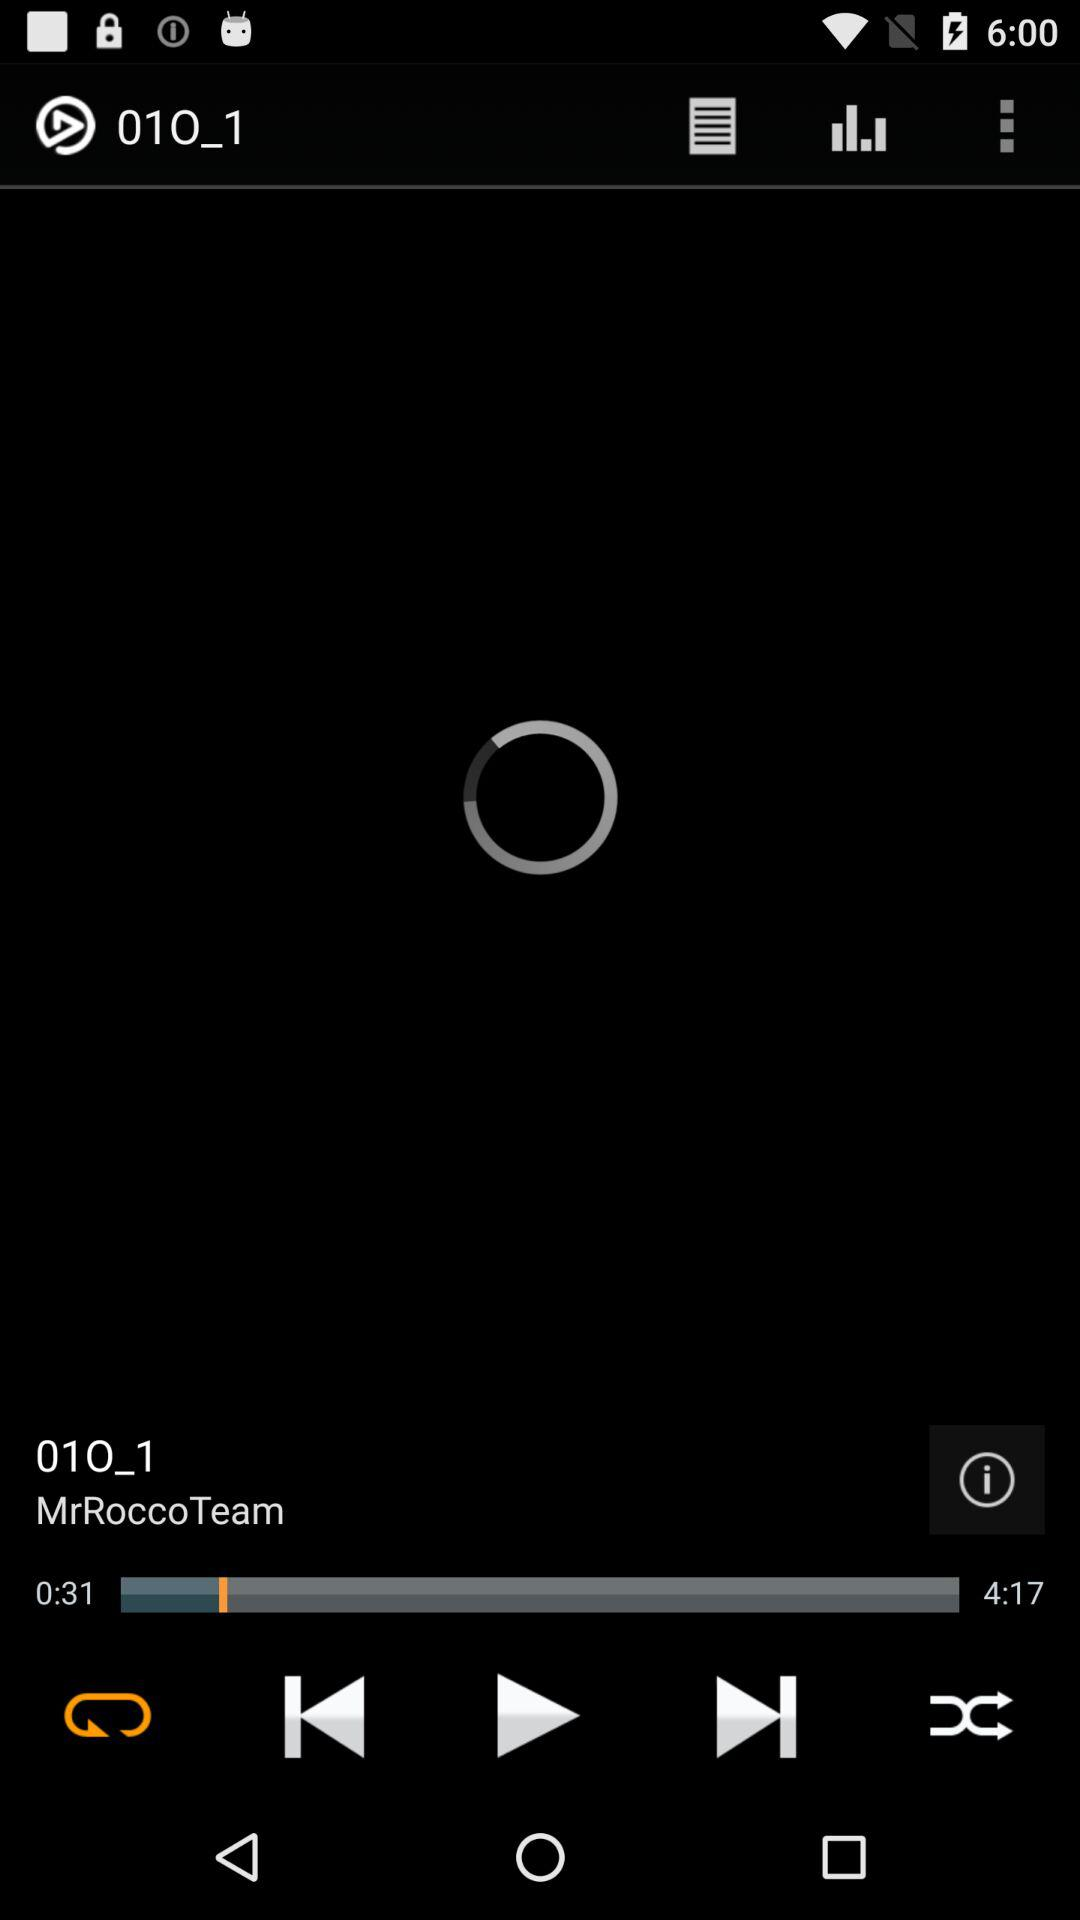What is the duration of the audio? The duration of the audio is 4 minutes 17 seconds. 